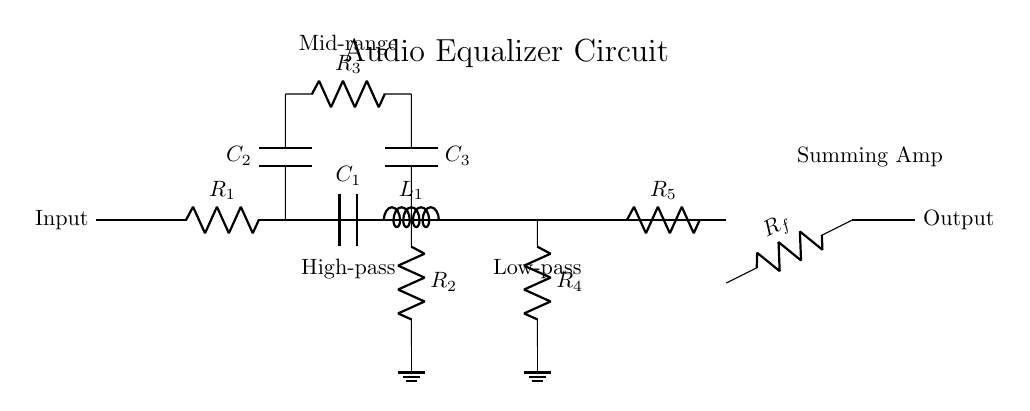What is the purpose of the capacitor C1? C1 forms a high-pass filter with resistor R1, allowing frequencies above a certain cutoff frequency to pass while attenuating lower frequencies.
Answer: High-pass filter How many resistors are present in the circuit? There are five resistors labeled R1, R2, R3, R4, and R5 in the circuit diagram.
Answer: Five What is the function of the op-amp in this circuit? The op-amp is used as a summing amplifier that combines signals from different filter stages to produce a single output signal.
Answer: Summing amplifier Which component is responsible for filtering mid-range frequencies? Capacitor C2 and resistor R3 are connected together to form a filter specifically designed for mid-range frequencies.
Answer: C2 and R3 What kind of filter is formed with L1 and R4? L1 and R4 together create a low-pass filter that allows low frequencies to pass while attenuating higher frequencies.
Answer: Low-pass filter What is the ground reference for the high-pass and low-pass filters? The ground reference for both the high-pass filter (R2) and the low-pass filter (R4) is shown at the bottom of the respective connections.
Answer: Ground 